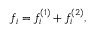Convert formula to latex. <formula><loc_0><loc_0><loc_500><loc_500>f _ { i } = f _ { i } ^ { ( 1 ) } + f _ { i } ^ { ( 2 ) } ,</formula> 